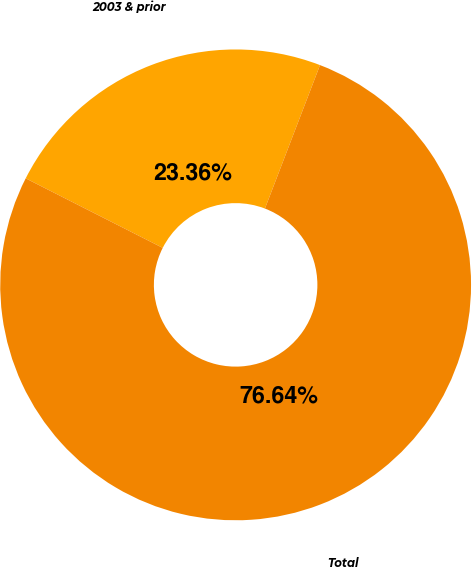Convert chart to OTSL. <chart><loc_0><loc_0><loc_500><loc_500><pie_chart><fcel>2003 & prior<fcel>Total<nl><fcel>23.36%<fcel>76.64%<nl></chart> 